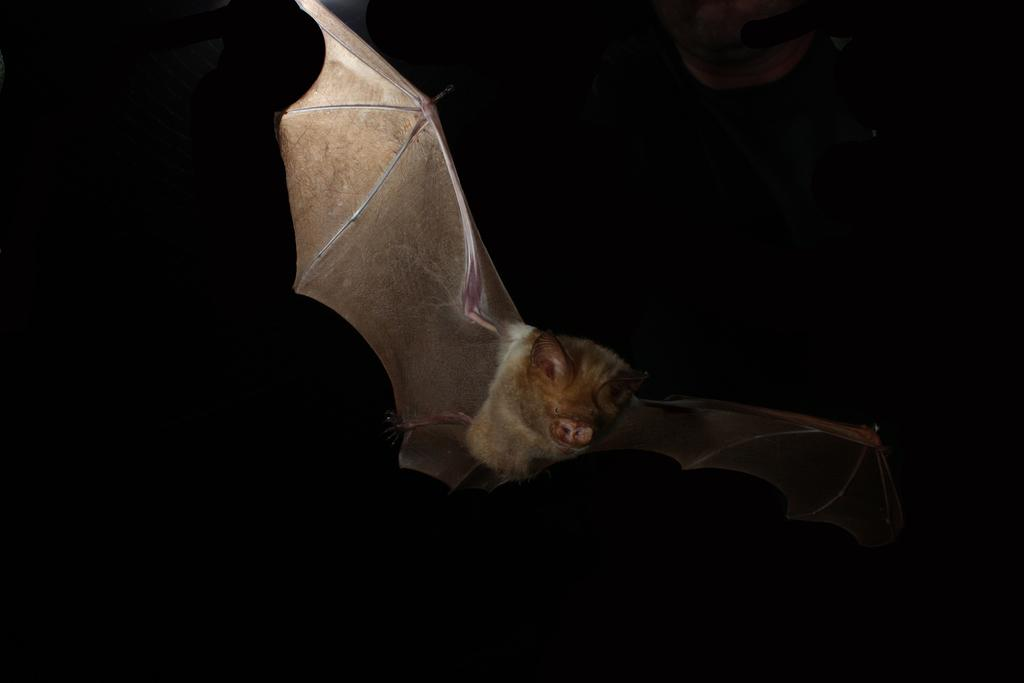What animal is present in the image? There is a bat in the image. What is the bat doing in the image? The bat is flying in the image. What is the color of the background in the image? The background of the image is black in color. When was the image taken? The image was taken in the image was taken in the dark. How many cats are sitting on the tramp in the image? There are no cats or tramp present in the image; it features a flying bat against a black background. What type of cloud can be seen in the image? There are no clouds visible in the image, as it is a dark background with a bat flying in front of it. 